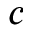Convert formula to latex. <formula><loc_0><loc_0><loc_500><loc_500>c</formula> 